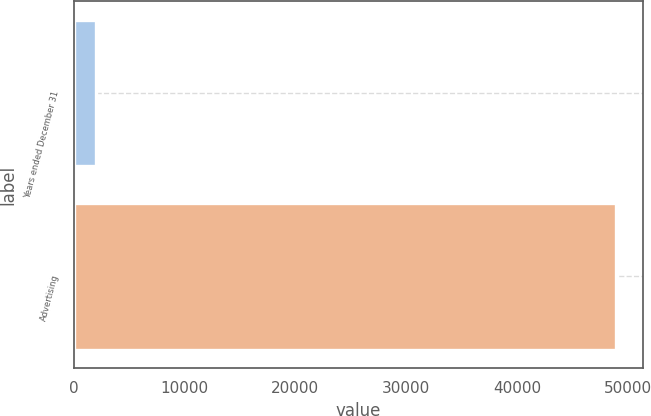Convert chart to OTSL. <chart><loc_0><loc_0><loc_500><loc_500><bar_chart><fcel>Years ended December 31<fcel>Advertising<nl><fcel>2012<fcel>48909<nl></chart> 